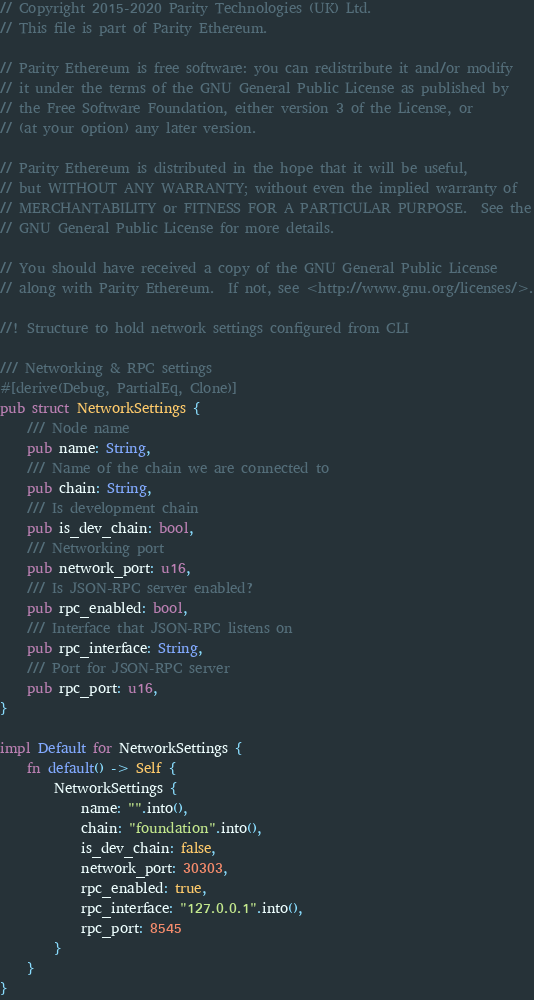Convert code to text. <code><loc_0><loc_0><loc_500><loc_500><_Rust_>// Copyright 2015-2020 Parity Technologies (UK) Ltd.
// This file is part of Parity Ethereum.

// Parity Ethereum is free software: you can redistribute it and/or modify
// it under the terms of the GNU General Public License as published by
// the Free Software Foundation, either version 3 of the License, or
// (at your option) any later version.

// Parity Ethereum is distributed in the hope that it will be useful,
// but WITHOUT ANY WARRANTY; without even the implied warranty of
// MERCHANTABILITY or FITNESS FOR A PARTICULAR PURPOSE.  See the
// GNU General Public License for more details.

// You should have received a copy of the GNU General Public License
// along with Parity Ethereum.  If not, see <http://www.gnu.org/licenses/>.

//! Structure to hold network settings configured from CLI

/// Networking & RPC settings
#[derive(Debug, PartialEq, Clone)]
pub struct NetworkSettings {
	/// Node name
	pub name: String,
	/// Name of the chain we are connected to
	pub chain: String,
	/// Is development chain
	pub is_dev_chain: bool,
	/// Networking port
	pub network_port: u16,
	/// Is JSON-RPC server enabled?
	pub rpc_enabled: bool,
	/// Interface that JSON-RPC listens on
	pub rpc_interface: String,
	/// Port for JSON-RPC server
	pub rpc_port: u16,
}

impl Default for NetworkSettings {
	fn default() -> Self {
		NetworkSettings {
			name: "".into(),
			chain: "foundation".into(),
			is_dev_chain: false,
			network_port: 30303,
			rpc_enabled: true,
			rpc_interface: "127.0.0.1".into(),
			rpc_port: 8545
		}
	}
}
</code> 